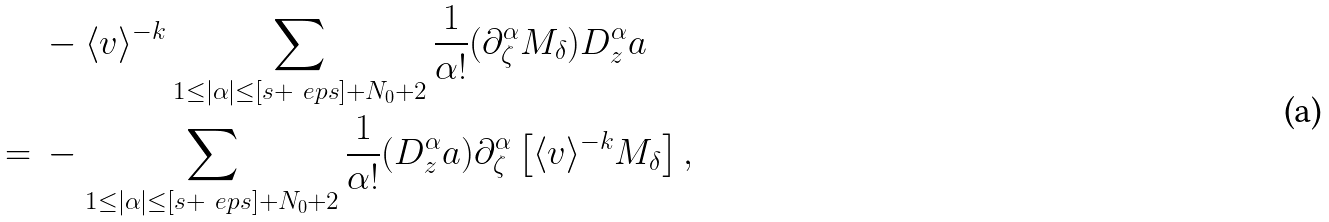Convert formula to latex. <formula><loc_0><loc_0><loc_500><loc_500>& \ - \langle v \rangle ^ { - k } \sum _ { 1 \leq | \alpha | \leq [ s + \ e p s ] + N _ { 0 } + 2 } \frac { 1 } { \alpha ! } ( \partial ^ { \alpha } _ { \zeta } M _ { \delta } ) D _ { z } ^ { \alpha } a \\ = & \ - \sum _ { 1 \leq | \alpha | \leq [ s + \ e p s ] + N _ { 0 } + 2 } \frac { 1 } { \alpha ! } ( D _ { z } ^ { \alpha } a ) \partial ^ { \alpha } _ { \zeta } \left [ \langle v \rangle ^ { - k } M _ { \delta } \right ] ,</formula> 